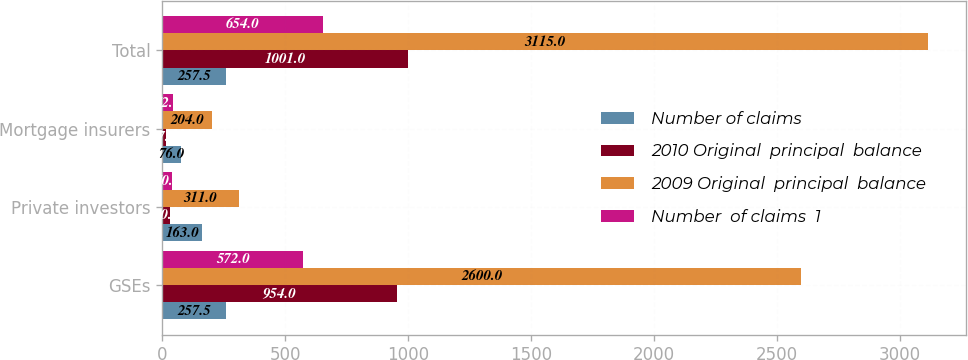Convert chart to OTSL. <chart><loc_0><loc_0><loc_500><loc_500><stacked_bar_chart><ecel><fcel>GSEs<fcel>Private investors<fcel>Mortgage insurers<fcel>Total<nl><fcel>Number of claims<fcel>257.5<fcel>163<fcel>76<fcel>257.5<nl><fcel>2010 Original  principal  balance<fcel>954<fcel>30<fcel>17<fcel>1001<nl><fcel>2009 Original  principal  balance<fcel>2600<fcel>311<fcel>204<fcel>3115<nl><fcel>Number  of claims  1<fcel>572<fcel>40<fcel>42<fcel>654<nl></chart> 